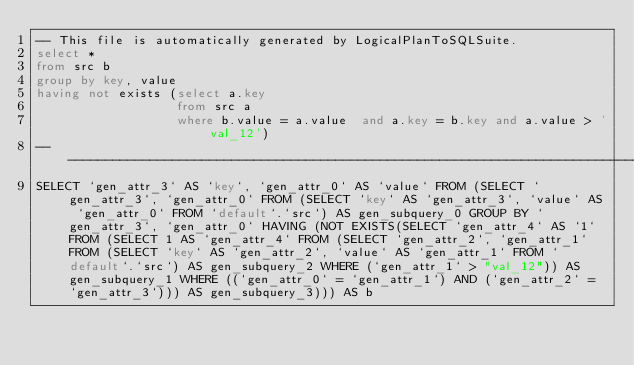Convert code to text. <code><loc_0><loc_0><loc_500><loc_500><_SQL_>-- This file is automatically generated by LogicalPlanToSQLSuite.
select *
from src b
group by key, value
having not exists (select a.key
                   from src a
                   where b.value = a.value  and a.key = b.key and a.value > 'val_12')
--------------------------------------------------------------------------------
SELECT `gen_attr_3` AS `key`, `gen_attr_0` AS `value` FROM (SELECT `gen_attr_3`, `gen_attr_0` FROM (SELECT `key` AS `gen_attr_3`, `value` AS `gen_attr_0` FROM `default`.`src`) AS gen_subquery_0 GROUP BY `gen_attr_3`, `gen_attr_0` HAVING (NOT EXISTS(SELECT `gen_attr_4` AS `1` FROM (SELECT 1 AS `gen_attr_4` FROM (SELECT `gen_attr_2`, `gen_attr_1` FROM (SELECT `key` AS `gen_attr_2`, `value` AS `gen_attr_1` FROM `default`.`src`) AS gen_subquery_2 WHERE (`gen_attr_1` > "val_12")) AS gen_subquery_1 WHERE ((`gen_attr_0` = `gen_attr_1`) AND (`gen_attr_2` = `gen_attr_3`))) AS gen_subquery_3))) AS b
</code> 